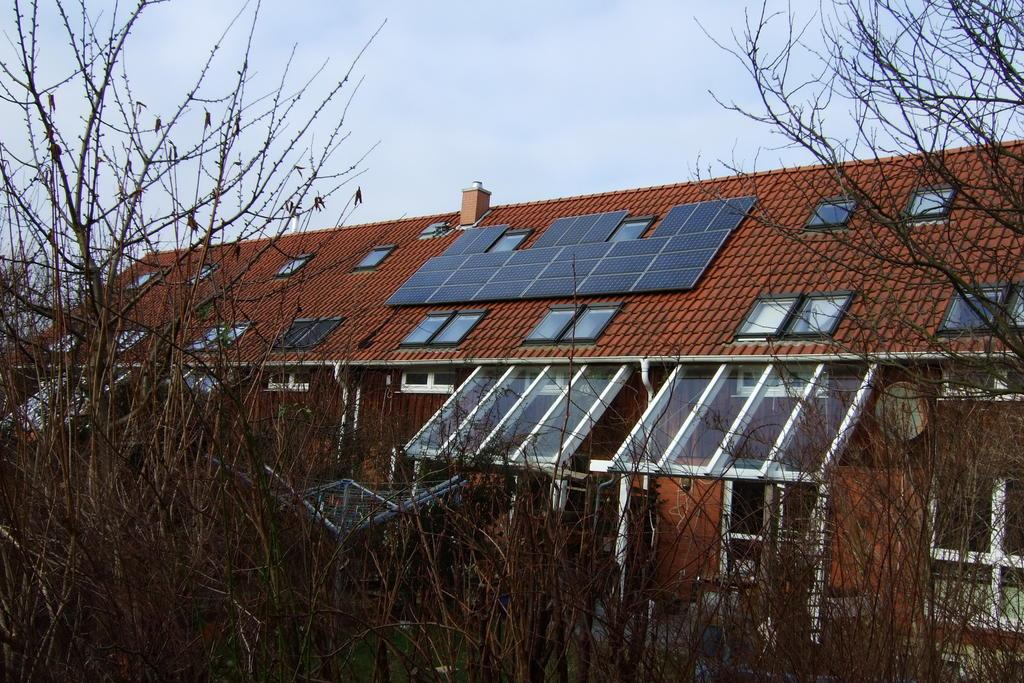What is the main structure in the middle of the image? There is a building in the middle of the image. What feature can be seen on top of the building? There are solar panels on the top of the building. What is visible at the top of the image? The sky is visible at the top of the image. What type of vegetation is in front of the building? There are trees in front of the building. How does the building care for the ring in the image? There is no ring present in the image, and the building does not care for any objects. 